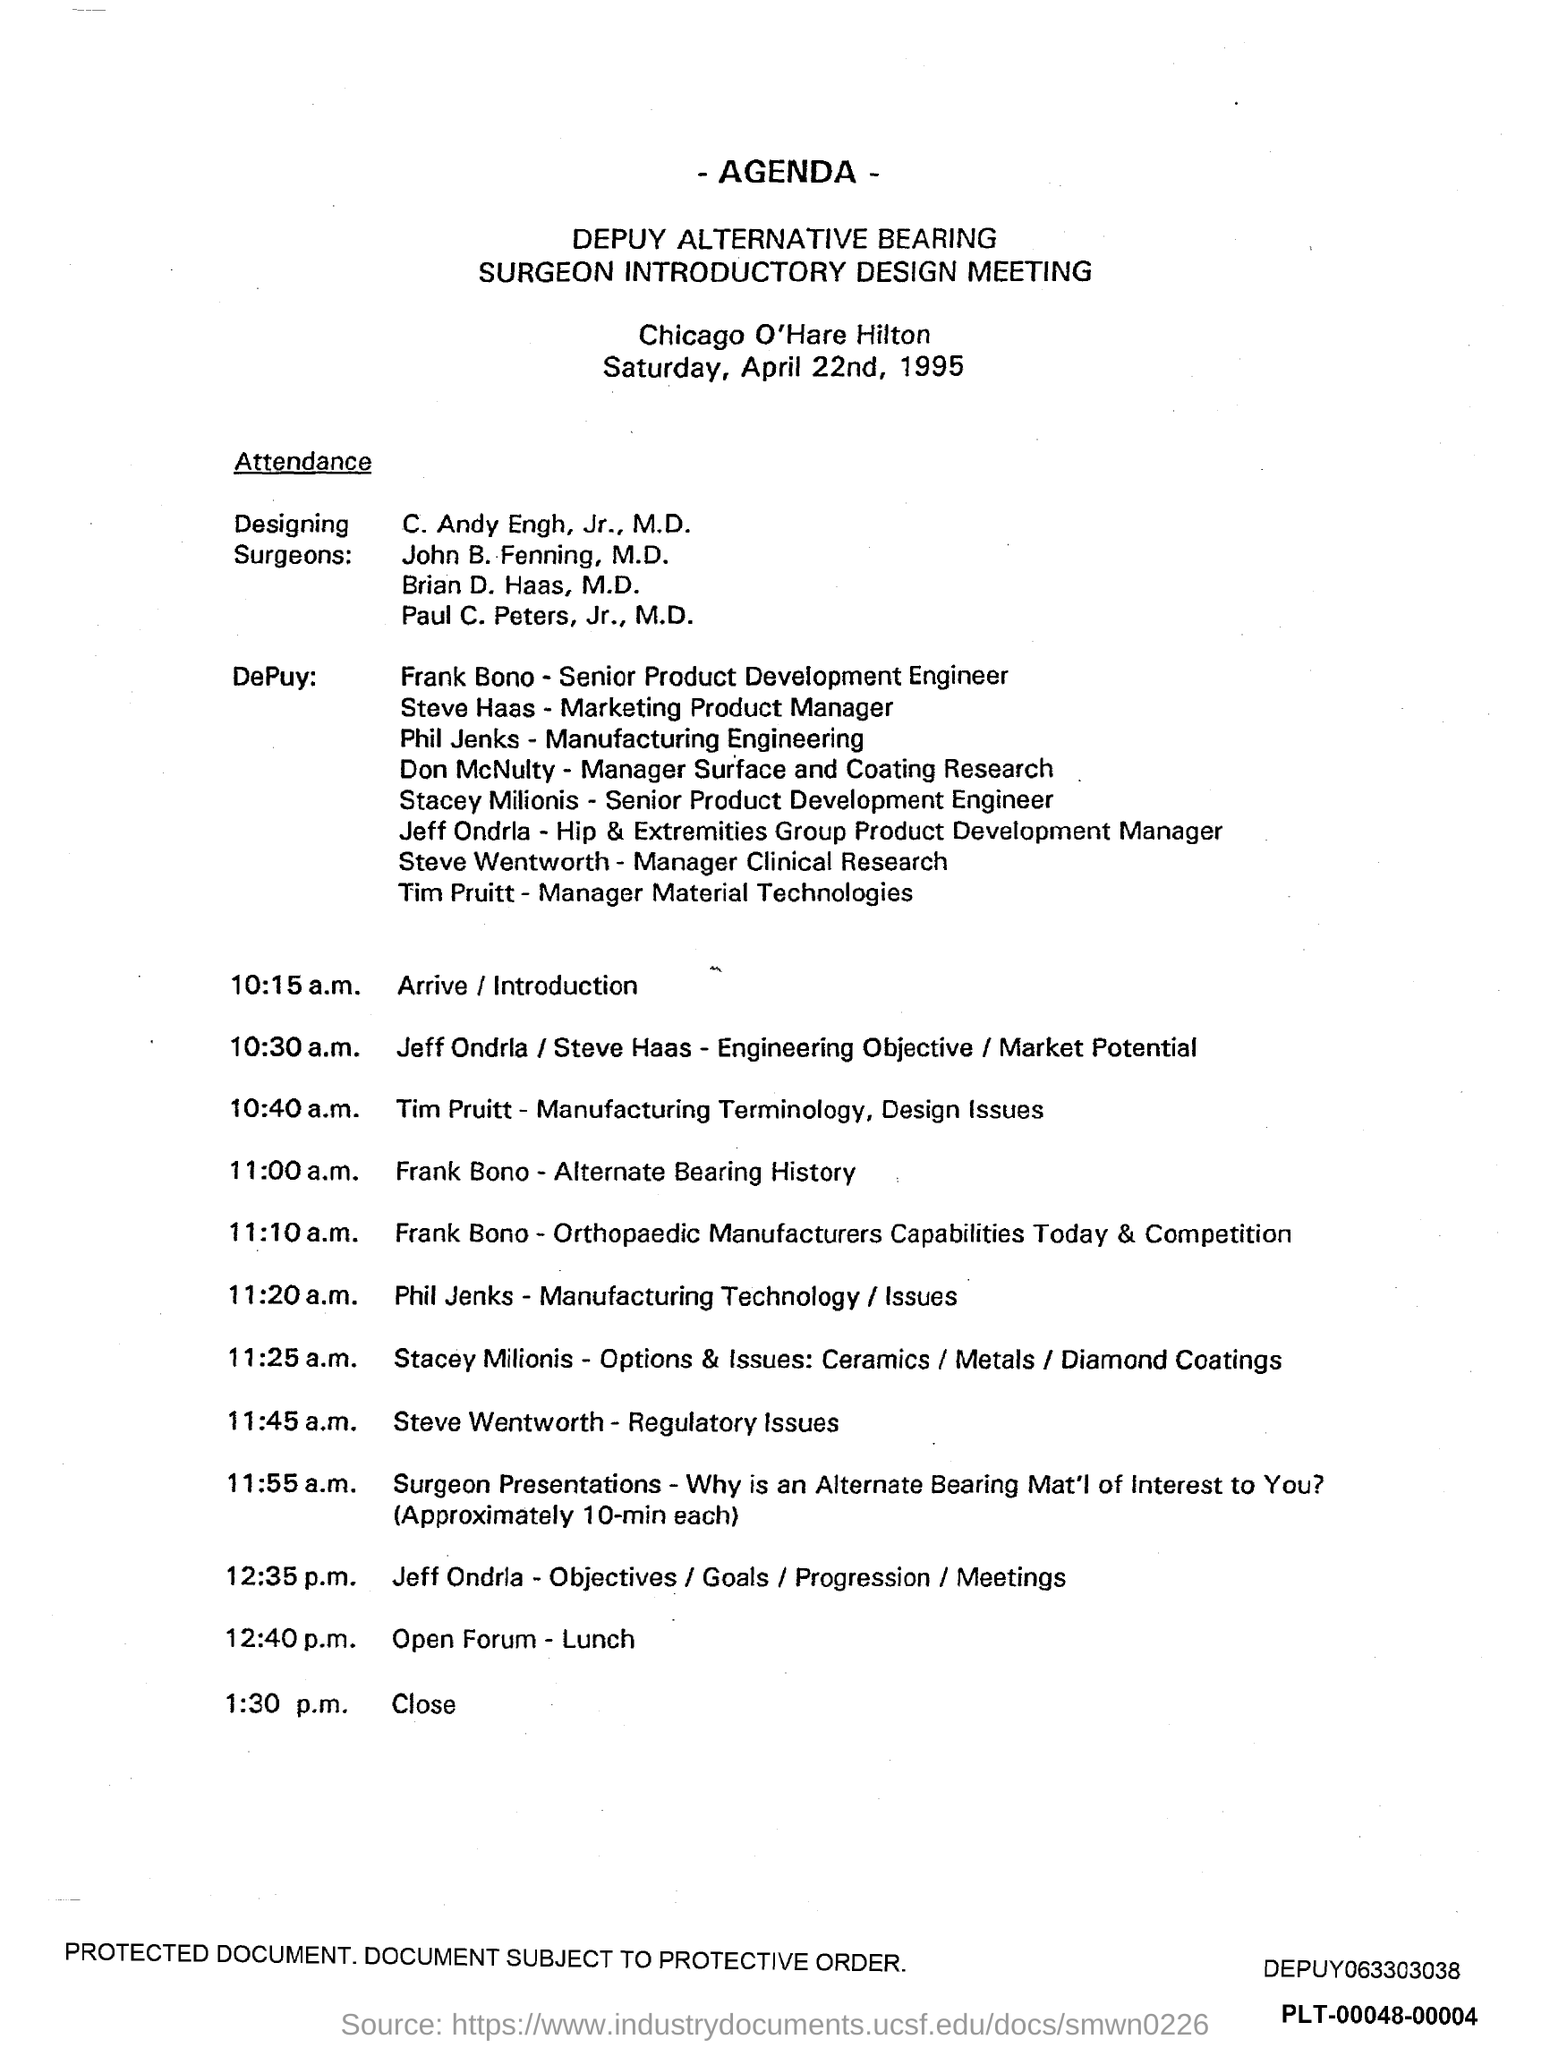Can you tell me who attended this design meeting? This design meeting was attended by a mix of surgeons and DePuy staff members. The surgeons included C. Andy Engh, Jr., M.D., John B. Fenning, M.D., Brian D. Haas, M.D., and Paul C. Peters, Jr., M.D. DePuy's team comprised of individuals from diverse fields such as product development, manufacturing engineering, and research, reflecting a collaborative approach to addressing the key issues in orthopaedic implant design. 